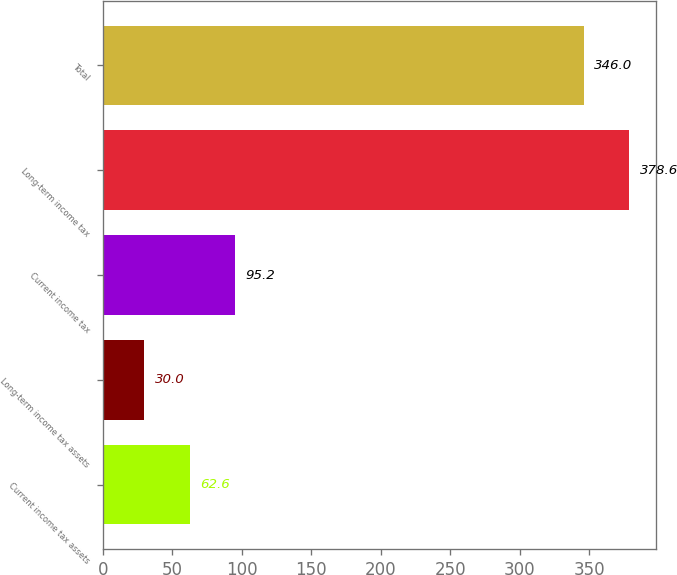Convert chart to OTSL. <chart><loc_0><loc_0><loc_500><loc_500><bar_chart><fcel>Current income tax assets<fcel>Long-term income tax assets<fcel>Current income tax<fcel>Long-term income tax<fcel>Total<nl><fcel>62.6<fcel>30<fcel>95.2<fcel>378.6<fcel>346<nl></chart> 